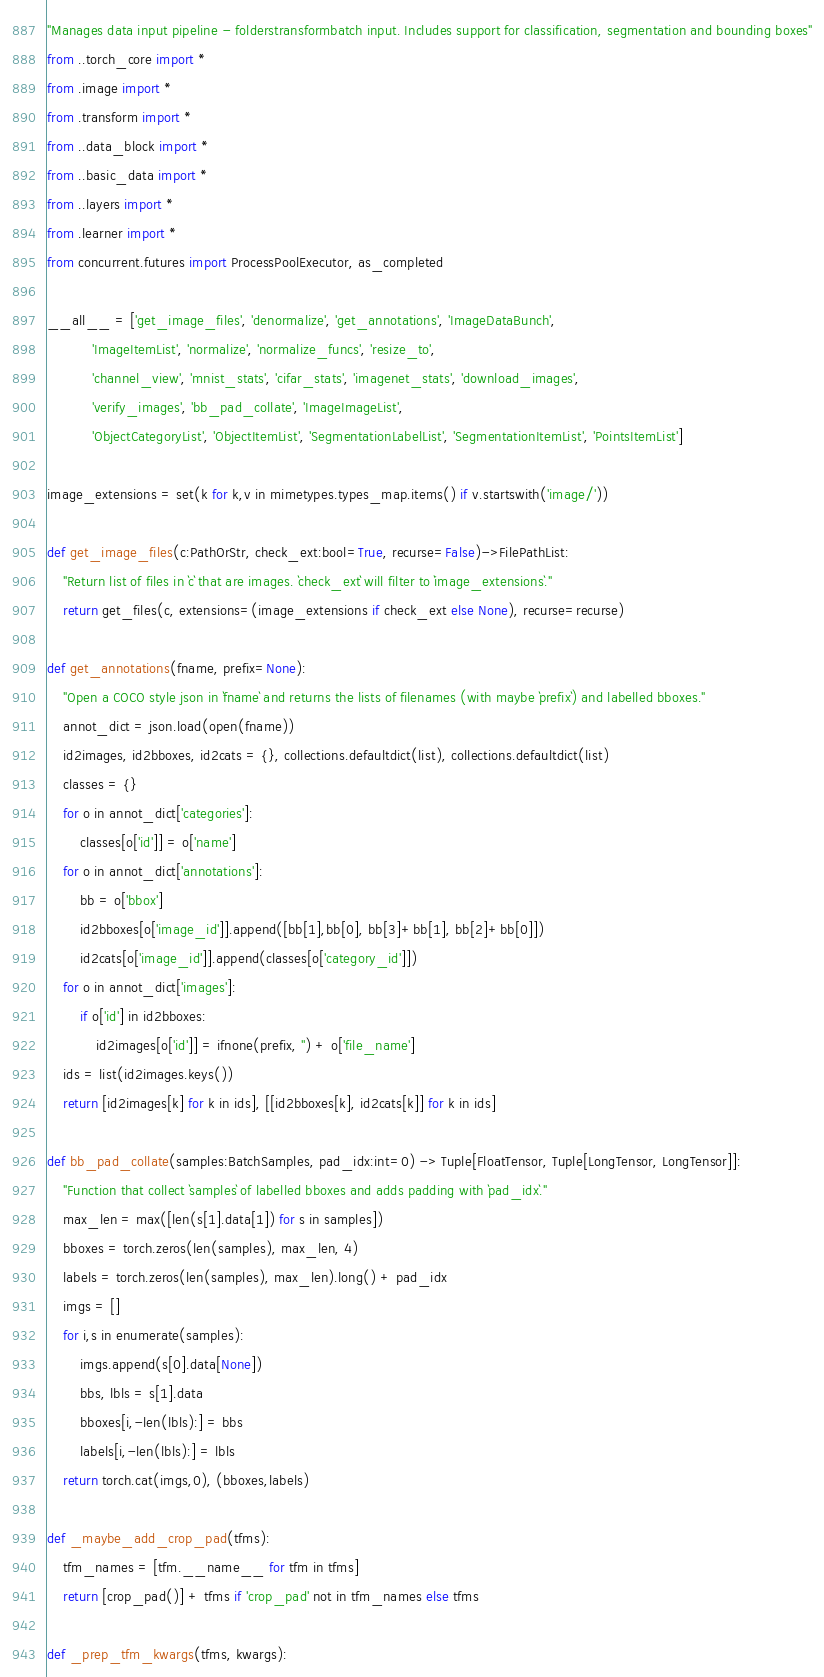<code> <loc_0><loc_0><loc_500><loc_500><_Python_>"Manages data input pipeline - folderstransformbatch input. Includes support for classification, segmentation and bounding boxes"
from ..torch_core import *
from .image import *
from .transform import *
from ..data_block import *
from ..basic_data import *
from ..layers import *
from .learner import *
from concurrent.futures import ProcessPoolExecutor, as_completed

__all__ = ['get_image_files', 'denormalize', 'get_annotations', 'ImageDataBunch',
           'ImageItemList', 'normalize', 'normalize_funcs', 'resize_to',
           'channel_view', 'mnist_stats', 'cifar_stats', 'imagenet_stats', 'download_images',
           'verify_images', 'bb_pad_collate', 'ImageImageList',
           'ObjectCategoryList', 'ObjectItemList', 'SegmentationLabelList', 'SegmentationItemList', 'PointsItemList']

image_extensions = set(k for k,v in mimetypes.types_map.items() if v.startswith('image/'))

def get_image_files(c:PathOrStr, check_ext:bool=True, recurse=False)->FilePathList:
    "Return list of files in `c` that are images. `check_ext` will filter to `image_extensions`."
    return get_files(c, extensions=(image_extensions if check_ext else None), recurse=recurse)

def get_annotations(fname, prefix=None):
    "Open a COCO style json in `fname` and returns the lists of filenames (with maybe `prefix`) and labelled bboxes."
    annot_dict = json.load(open(fname))
    id2images, id2bboxes, id2cats = {}, collections.defaultdict(list), collections.defaultdict(list)
    classes = {}
    for o in annot_dict['categories']:
        classes[o['id']] = o['name']
    for o in annot_dict['annotations']:
        bb = o['bbox']
        id2bboxes[o['image_id']].append([bb[1],bb[0], bb[3]+bb[1], bb[2]+bb[0]])
        id2cats[o['image_id']].append(classes[o['category_id']])
    for o in annot_dict['images']:
        if o['id'] in id2bboxes:
            id2images[o['id']] = ifnone(prefix, '') + o['file_name']
    ids = list(id2images.keys())
    return [id2images[k] for k in ids], [[id2bboxes[k], id2cats[k]] for k in ids]

def bb_pad_collate(samples:BatchSamples, pad_idx:int=0) -> Tuple[FloatTensor, Tuple[LongTensor, LongTensor]]:
    "Function that collect `samples` of labelled bboxes and adds padding with `pad_idx`."
    max_len = max([len(s[1].data[1]) for s in samples])
    bboxes = torch.zeros(len(samples), max_len, 4)
    labels = torch.zeros(len(samples), max_len).long() + pad_idx
    imgs = []
    for i,s in enumerate(samples):
        imgs.append(s[0].data[None])
        bbs, lbls = s[1].data
        bboxes[i,-len(lbls):] = bbs
        labels[i,-len(lbls):] = lbls
    return torch.cat(imgs,0), (bboxes,labels)

def _maybe_add_crop_pad(tfms):
    tfm_names = [tfm.__name__ for tfm in tfms]
    return [crop_pad()] + tfms if 'crop_pad' not in tfm_names else tfms

def _prep_tfm_kwargs(tfms, kwargs):</code> 